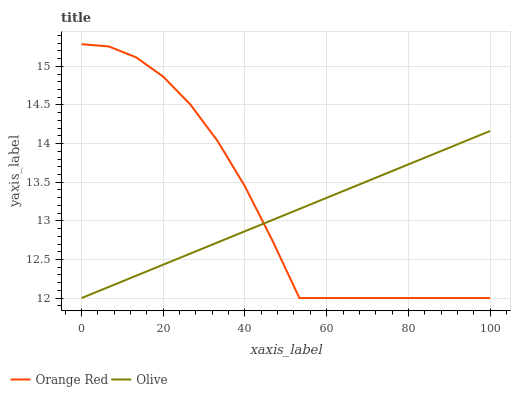Does Olive have the minimum area under the curve?
Answer yes or no. Yes. Does Orange Red have the maximum area under the curve?
Answer yes or no. Yes. Does Orange Red have the minimum area under the curve?
Answer yes or no. No. Is Olive the smoothest?
Answer yes or no. Yes. Is Orange Red the roughest?
Answer yes or no. Yes. Is Orange Red the smoothest?
Answer yes or no. No. Does Orange Red have the highest value?
Answer yes or no. Yes. Does Olive intersect Orange Red?
Answer yes or no. Yes. Is Olive less than Orange Red?
Answer yes or no. No. Is Olive greater than Orange Red?
Answer yes or no. No. 